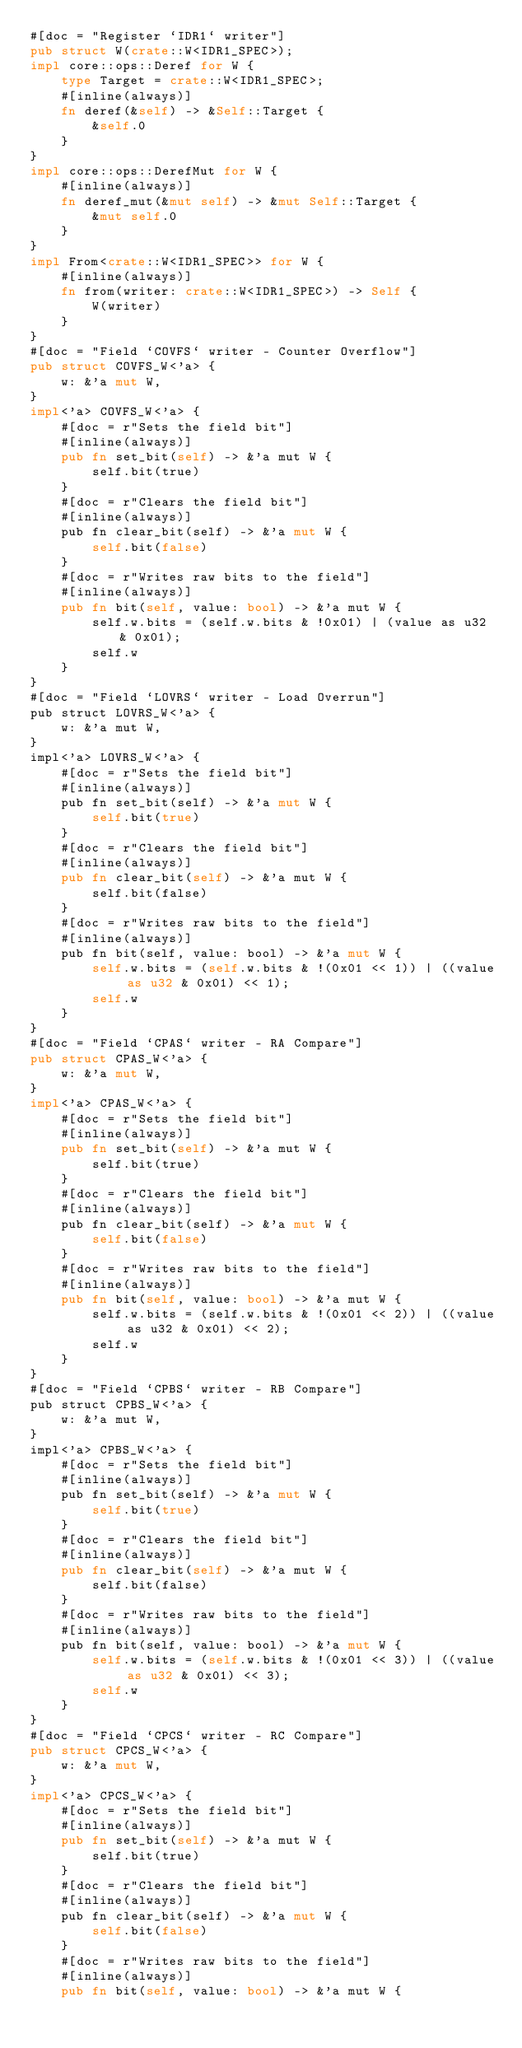Convert code to text. <code><loc_0><loc_0><loc_500><loc_500><_Rust_>#[doc = "Register `IDR1` writer"]
pub struct W(crate::W<IDR1_SPEC>);
impl core::ops::Deref for W {
    type Target = crate::W<IDR1_SPEC>;
    #[inline(always)]
    fn deref(&self) -> &Self::Target {
        &self.0
    }
}
impl core::ops::DerefMut for W {
    #[inline(always)]
    fn deref_mut(&mut self) -> &mut Self::Target {
        &mut self.0
    }
}
impl From<crate::W<IDR1_SPEC>> for W {
    #[inline(always)]
    fn from(writer: crate::W<IDR1_SPEC>) -> Self {
        W(writer)
    }
}
#[doc = "Field `COVFS` writer - Counter Overflow"]
pub struct COVFS_W<'a> {
    w: &'a mut W,
}
impl<'a> COVFS_W<'a> {
    #[doc = r"Sets the field bit"]
    #[inline(always)]
    pub fn set_bit(self) -> &'a mut W {
        self.bit(true)
    }
    #[doc = r"Clears the field bit"]
    #[inline(always)]
    pub fn clear_bit(self) -> &'a mut W {
        self.bit(false)
    }
    #[doc = r"Writes raw bits to the field"]
    #[inline(always)]
    pub fn bit(self, value: bool) -> &'a mut W {
        self.w.bits = (self.w.bits & !0x01) | (value as u32 & 0x01);
        self.w
    }
}
#[doc = "Field `LOVRS` writer - Load Overrun"]
pub struct LOVRS_W<'a> {
    w: &'a mut W,
}
impl<'a> LOVRS_W<'a> {
    #[doc = r"Sets the field bit"]
    #[inline(always)]
    pub fn set_bit(self) -> &'a mut W {
        self.bit(true)
    }
    #[doc = r"Clears the field bit"]
    #[inline(always)]
    pub fn clear_bit(self) -> &'a mut W {
        self.bit(false)
    }
    #[doc = r"Writes raw bits to the field"]
    #[inline(always)]
    pub fn bit(self, value: bool) -> &'a mut W {
        self.w.bits = (self.w.bits & !(0x01 << 1)) | ((value as u32 & 0x01) << 1);
        self.w
    }
}
#[doc = "Field `CPAS` writer - RA Compare"]
pub struct CPAS_W<'a> {
    w: &'a mut W,
}
impl<'a> CPAS_W<'a> {
    #[doc = r"Sets the field bit"]
    #[inline(always)]
    pub fn set_bit(self) -> &'a mut W {
        self.bit(true)
    }
    #[doc = r"Clears the field bit"]
    #[inline(always)]
    pub fn clear_bit(self) -> &'a mut W {
        self.bit(false)
    }
    #[doc = r"Writes raw bits to the field"]
    #[inline(always)]
    pub fn bit(self, value: bool) -> &'a mut W {
        self.w.bits = (self.w.bits & !(0x01 << 2)) | ((value as u32 & 0x01) << 2);
        self.w
    }
}
#[doc = "Field `CPBS` writer - RB Compare"]
pub struct CPBS_W<'a> {
    w: &'a mut W,
}
impl<'a> CPBS_W<'a> {
    #[doc = r"Sets the field bit"]
    #[inline(always)]
    pub fn set_bit(self) -> &'a mut W {
        self.bit(true)
    }
    #[doc = r"Clears the field bit"]
    #[inline(always)]
    pub fn clear_bit(self) -> &'a mut W {
        self.bit(false)
    }
    #[doc = r"Writes raw bits to the field"]
    #[inline(always)]
    pub fn bit(self, value: bool) -> &'a mut W {
        self.w.bits = (self.w.bits & !(0x01 << 3)) | ((value as u32 & 0x01) << 3);
        self.w
    }
}
#[doc = "Field `CPCS` writer - RC Compare"]
pub struct CPCS_W<'a> {
    w: &'a mut W,
}
impl<'a> CPCS_W<'a> {
    #[doc = r"Sets the field bit"]
    #[inline(always)]
    pub fn set_bit(self) -> &'a mut W {
        self.bit(true)
    }
    #[doc = r"Clears the field bit"]
    #[inline(always)]
    pub fn clear_bit(self) -> &'a mut W {
        self.bit(false)
    }
    #[doc = r"Writes raw bits to the field"]
    #[inline(always)]
    pub fn bit(self, value: bool) -> &'a mut W {</code> 